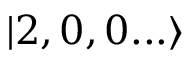Convert formula to latex. <formula><loc_0><loc_0><loc_500><loc_500>| 2 , 0 , 0 \dots \rangle</formula> 